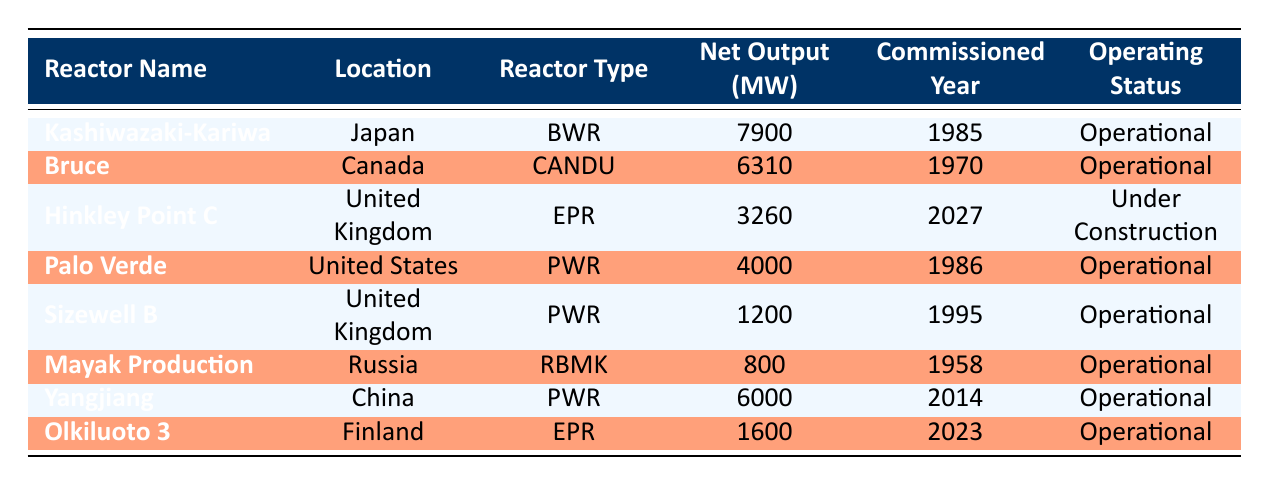What is the net output of the Kashiwazaki-Kariwa Nuclear Power Plant? The table shows the net output for each reactor. For the Kashiwazaki-Kariwa, the net output listed is 7900 MW.
Answer: 7900 MW Which reactor has the highest net output, and what is that output? By comparing the net outputs in the table, the Kashiwazaki-Kariwa Nuclear Power Plant has the highest output of 7900 MW.
Answer: Kashiwazaki-Kariwa Nuclear Power Plant, 7900 MW Are there any nuclear reactors that were commissioned in the year 1986? Looking at the table, there is one reactor, the Palo Verde Nuclear Generating Station, which was commissioned in 1986.
Answer: Yes What is the total net output of all operational reactors in the table? To find the total output, we add the outputs of all operational reactors: 7900 + 6310 + 4000 + 1200 + 800 + 6000 + 1600 = 23910 MW. Thus, the total is 23910 MW.
Answer: 23910 MW Is the Hinkley Point C reactor operational? The table indicates that the Hinkley Point C reactor is currently under construction, not operational.
Answer: No Which reactor type has the highest net output, based on the reactors listed, and what is that output? After analyzing, the BWR reactor type (Kashiwazaki-Kariwa) has the highest output of 7900 MW, as no other reactor type matches or exceeds this value.
Answer: BWR, 7900 MW Which country has the reactor with the earliest commissioning year? The Mayak Production Association in Russia was commissioned in 1958, which is earlier than any other reactor listed in the table.
Answer: Russia What percentage of total net output is contributed by the Yangjiang Nuclear Power Station? The Yangjiang output is 6000 MW. Total output is 23910 MW. The percentage contribution is (6000 / 23910) * 100 ≈ 25.1%.
Answer: Approximately 25.1% How many reactors are classified as EPR in the table? The table lists two reactors classified as EPR: Hinkley Point C and Olkiluoto 3. Therefore, the count is two.
Answer: 2 